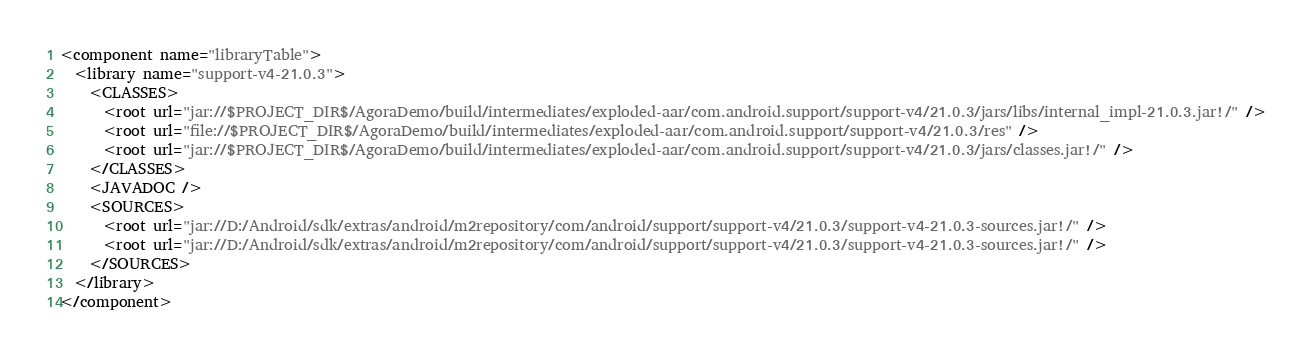Convert code to text. <code><loc_0><loc_0><loc_500><loc_500><_XML_><component name="libraryTable">
  <library name="support-v4-21.0.3">
    <CLASSES>
      <root url="jar://$PROJECT_DIR$/AgoraDemo/build/intermediates/exploded-aar/com.android.support/support-v4/21.0.3/jars/libs/internal_impl-21.0.3.jar!/" />
      <root url="file://$PROJECT_DIR$/AgoraDemo/build/intermediates/exploded-aar/com.android.support/support-v4/21.0.3/res" />
      <root url="jar://$PROJECT_DIR$/AgoraDemo/build/intermediates/exploded-aar/com.android.support/support-v4/21.0.3/jars/classes.jar!/" />
    </CLASSES>
    <JAVADOC />
    <SOURCES>
      <root url="jar://D:/Android/sdk/extras/android/m2repository/com/android/support/support-v4/21.0.3/support-v4-21.0.3-sources.jar!/" />
      <root url="jar://D:/Android/sdk/extras/android/m2repository/com/android/support/support-v4/21.0.3/support-v4-21.0.3-sources.jar!/" />
    </SOURCES>
  </library>
</component></code> 